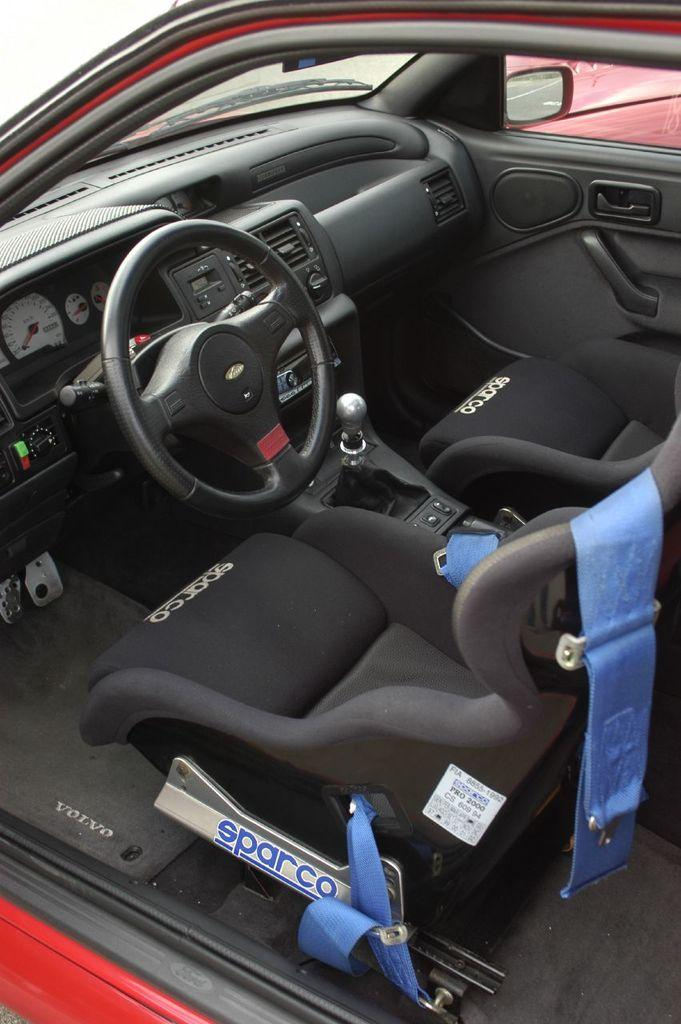What type of space is shown in the image? The image shows the inside of a vehicle. What can be found inside the vehicle? There are seats and a steering wheel present in the vehicle. What instrument is used to measure the speed of the vehicle? There is a speedometer in the vehicle. Are there any other objects visible inside the vehicle? Yes, there are other objects visible in the vehicle. What type of brick is used to build the kite in the image? There is no brick or kite present in the image; it shows the inside of a vehicle. 